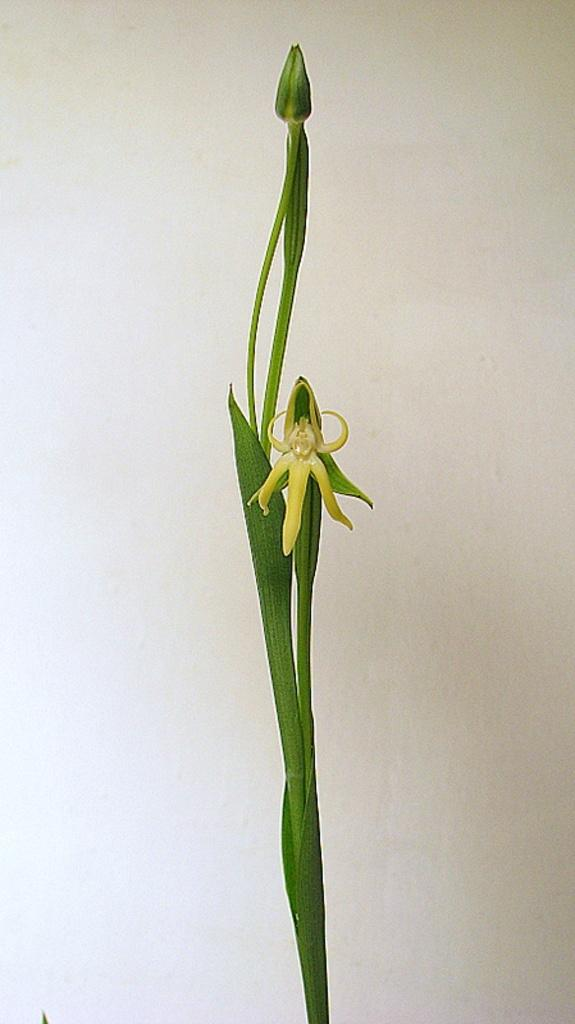What is the main subject in the center of the image? There is a plant in the center of the image. What color is the background of the image? The background of the image is white in color. What invention is being demonstrated in the image? There is no invention being demonstrated in the image; it features a plant in the center and a white background. What is the distance between the plant and the edge of the image? The distance between the plant and the edge of the image cannot be determined from the image alone, as it does not provide any reference points for measurement. 